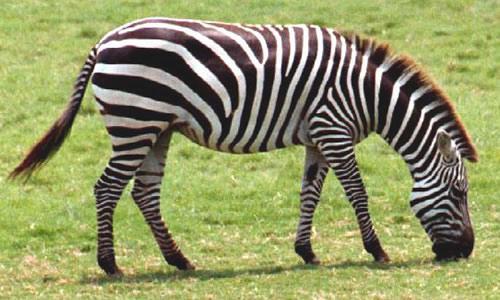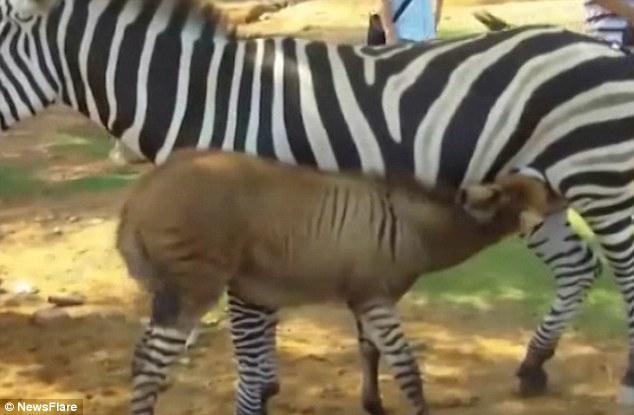The first image is the image on the left, the second image is the image on the right. Analyze the images presented: Is the assertion "In one image there are two zebras walking in the same direction." valid? Answer yes or no. No. 